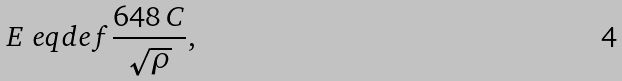<formula> <loc_0><loc_0><loc_500><loc_500>E \ e q d e f \frac { 6 4 8 \, C } { \sqrt { \rho } } ,</formula> 